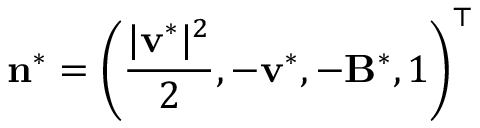Convert formula to latex. <formula><loc_0><loc_0><loc_500><loc_500>n ^ { * } = \left ( \frac { | v ^ { * } | ^ { 2 } } { 2 } , - v ^ { * } , - B ^ { * } , 1 \right ) ^ { \top }</formula> 